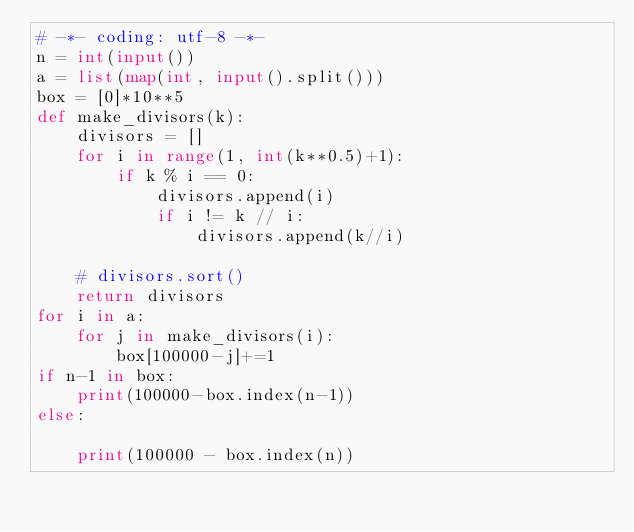<code> <loc_0><loc_0><loc_500><loc_500><_Python_># -*- coding: utf-8 -*-
n = int(input())
a = list(map(int, input().split()))
box = [0]*10**5
def make_divisors(k):
    divisors = []
    for i in range(1, int(k**0.5)+1):
        if k % i == 0:
            divisors.append(i)
            if i != k // i:
                divisors.append(k//i)

    # divisors.sort()
    return divisors
for i in a:
    for j in make_divisors(i):
        box[100000-j]+=1 
if n-1 in box:
    print(100000-box.index(n-1))
else:
  
    print(100000 - box.index(n))</code> 